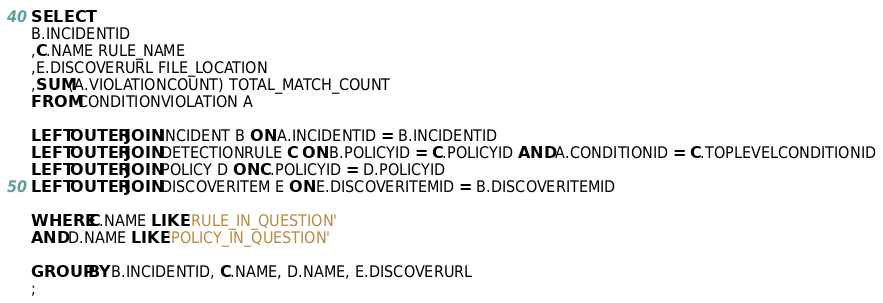Convert code to text. <code><loc_0><loc_0><loc_500><loc_500><_SQL_>SELECT 
B.INCIDENTID
,C.NAME RULE_NAME
,E.DISCOVERURL FILE_LOCATION
,SUM(A.VIOLATIONCOUNT) TOTAL_MATCH_COUNT
FROM CONDITIONVIOLATION A

LEFT OUTER JOIN INCIDENT B ON A.INCIDENTID = B.INCIDENTID
LEFT OUTER JOIN DETECTIONRULE C ON B.POLICYID = C.POLICYID AND A.CONDITIONID = C.TOPLEVELCONDITIONID
LEFT OUTER JOIN POLICY D ON C.POLICYID = D.POLICYID
LEFT OUTER JOIN DISCOVERITEM E ON E.DISCOVERITEMID = B.DISCOVERITEMID

WHERE C.NAME LIKE 'RULE_IN_QUESTION'
AND D.NAME LIKE 'POLICY_IN_QUESTION'

GROUP BY B.INCIDENTID, C.NAME, D.NAME, E.DISCOVERURL
; 
</code> 